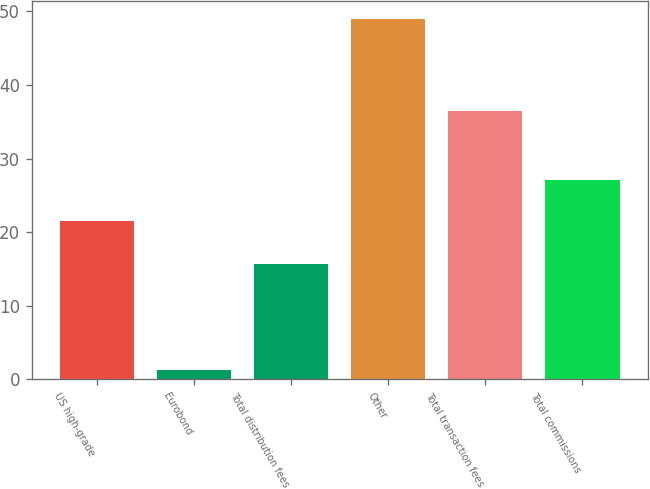Convert chart to OTSL. <chart><loc_0><loc_0><loc_500><loc_500><bar_chart><fcel>US high-grade<fcel>Eurobond<fcel>Total distribution fees<fcel>Other<fcel>Total transaction fees<fcel>Total commissions<nl><fcel>21.5<fcel>1.3<fcel>15.7<fcel>49<fcel>36.5<fcel>27.1<nl></chart> 